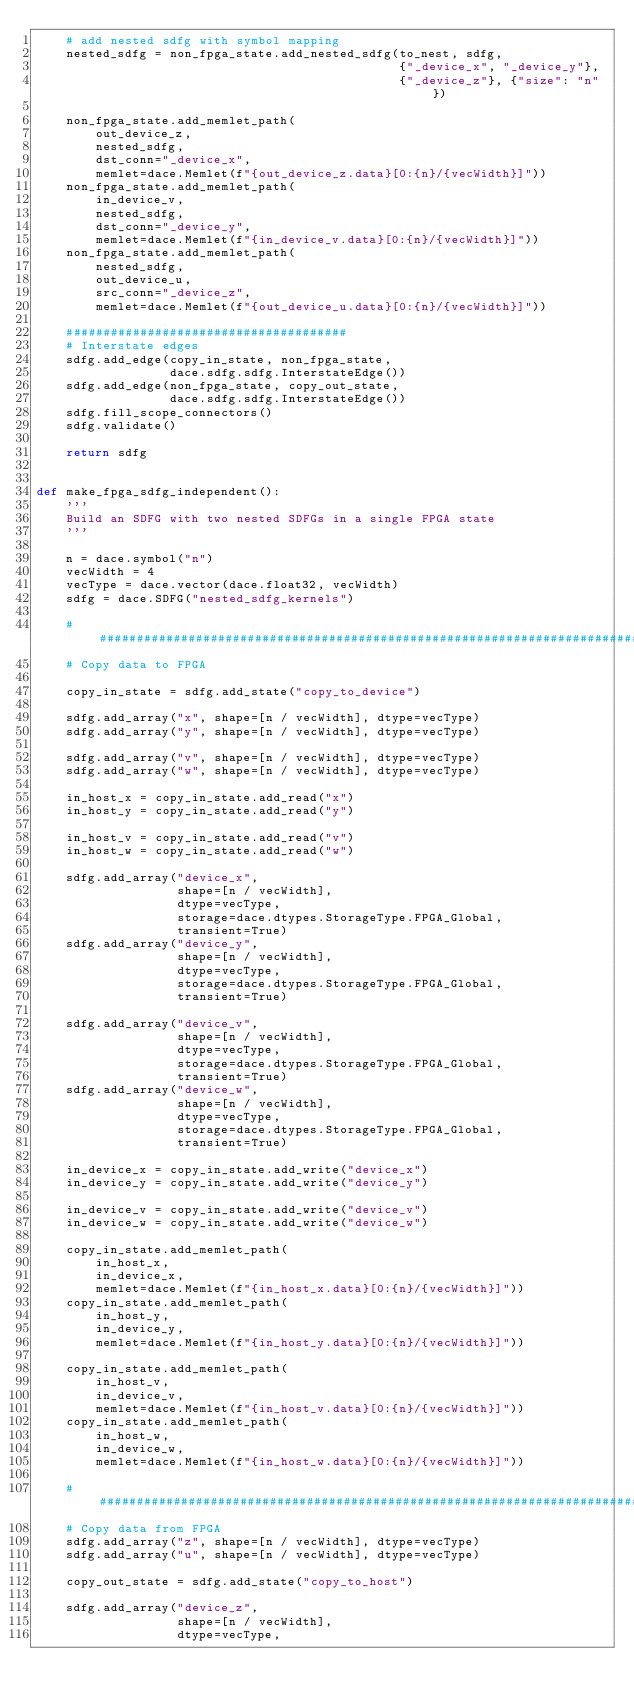<code> <loc_0><loc_0><loc_500><loc_500><_Python_>    # add nested sdfg with symbol mapping
    nested_sdfg = non_fpga_state.add_nested_sdfg(to_nest, sdfg,
                                                 {"_device_x", "_device_y"},
                                                 {"_device_z"}, {"size": "n"})

    non_fpga_state.add_memlet_path(
        out_device_z,
        nested_sdfg,
        dst_conn="_device_x",
        memlet=dace.Memlet(f"{out_device_z.data}[0:{n}/{vecWidth}]"))
    non_fpga_state.add_memlet_path(
        in_device_v,
        nested_sdfg,
        dst_conn="_device_y",
        memlet=dace.Memlet(f"{in_device_v.data}[0:{n}/{vecWidth}]"))
    non_fpga_state.add_memlet_path(
        nested_sdfg,
        out_device_u,
        src_conn="_device_z",
        memlet=dace.Memlet(f"{out_device_u.data}[0:{n}/{vecWidth}]"))

    ######################################
    # Interstate edges
    sdfg.add_edge(copy_in_state, non_fpga_state,
                  dace.sdfg.sdfg.InterstateEdge())
    sdfg.add_edge(non_fpga_state, copy_out_state,
                  dace.sdfg.sdfg.InterstateEdge())
    sdfg.fill_scope_connectors()
    sdfg.validate()

    return sdfg


def make_fpga_sdfg_independent():
    '''
    Build an SDFG with two nested SDFGs in a single FPGA state
    '''

    n = dace.symbol("n")
    vecWidth = 4
    vecType = dace.vector(dace.float32, vecWidth)
    sdfg = dace.SDFG("nested_sdfg_kernels")

    ###########################################################################
    # Copy data to FPGA

    copy_in_state = sdfg.add_state("copy_to_device")

    sdfg.add_array("x", shape=[n / vecWidth], dtype=vecType)
    sdfg.add_array("y", shape=[n / vecWidth], dtype=vecType)

    sdfg.add_array("v", shape=[n / vecWidth], dtype=vecType)
    sdfg.add_array("w", shape=[n / vecWidth], dtype=vecType)

    in_host_x = copy_in_state.add_read("x")
    in_host_y = copy_in_state.add_read("y")

    in_host_v = copy_in_state.add_read("v")
    in_host_w = copy_in_state.add_read("w")

    sdfg.add_array("device_x",
                   shape=[n / vecWidth],
                   dtype=vecType,
                   storage=dace.dtypes.StorageType.FPGA_Global,
                   transient=True)
    sdfg.add_array("device_y",
                   shape=[n / vecWidth],
                   dtype=vecType,
                   storage=dace.dtypes.StorageType.FPGA_Global,
                   transient=True)

    sdfg.add_array("device_v",
                   shape=[n / vecWidth],
                   dtype=vecType,
                   storage=dace.dtypes.StorageType.FPGA_Global,
                   transient=True)
    sdfg.add_array("device_w",
                   shape=[n / vecWidth],
                   dtype=vecType,
                   storage=dace.dtypes.StorageType.FPGA_Global,
                   transient=True)

    in_device_x = copy_in_state.add_write("device_x")
    in_device_y = copy_in_state.add_write("device_y")

    in_device_v = copy_in_state.add_write("device_v")
    in_device_w = copy_in_state.add_write("device_w")

    copy_in_state.add_memlet_path(
        in_host_x,
        in_device_x,
        memlet=dace.Memlet(f"{in_host_x.data}[0:{n}/{vecWidth}]"))
    copy_in_state.add_memlet_path(
        in_host_y,
        in_device_y,
        memlet=dace.Memlet(f"{in_host_y.data}[0:{n}/{vecWidth}]"))

    copy_in_state.add_memlet_path(
        in_host_v,
        in_device_v,
        memlet=dace.Memlet(f"{in_host_v.data}[0:{n}/{vecWidth}]"))
    copy_in_state.add_memlet_path(
        in_host_w,
        in_device_w,
        memlet=dace.Memlet(f"{in_host_w.data}[0:{n}/{vecWidth}]"))

    ###########################################################################
    # Copy data from FPGA
    sdfg.add_array("z", shape=[n / vecWidth], dtype=vecType)
    sdfg.add_array("u", shape=[n / vecWidth], dtype=vecType)

    copy_out_state = sdfg.add_state("copy_to_host")

    sdfg.add_array("device_z",
                   shape=[n / vecWidth],
                   dtype=vecType,</code> 